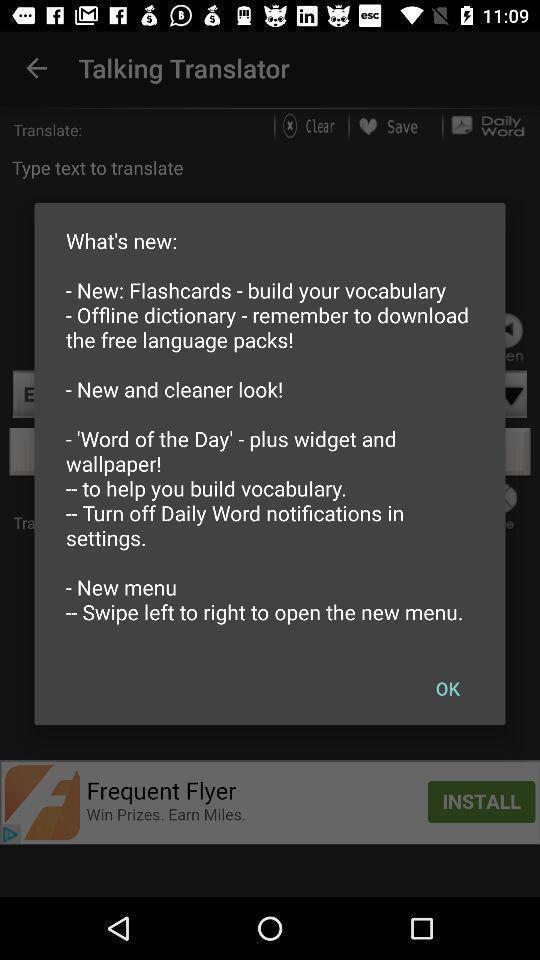Summarize the main components in this picture. Pop-up showing word learning information. 